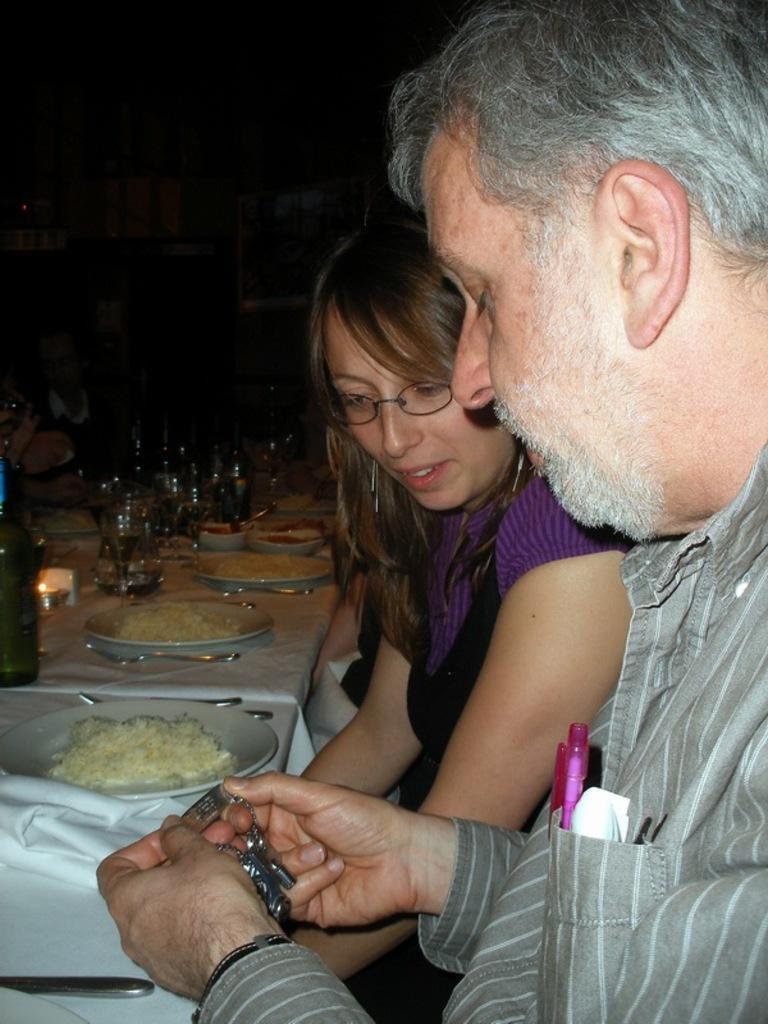Describe this image in one or two sentences. In this image I can see two persons are sitting and in the front I can see one of them is holding a silver colour thing, in his pocket I can see a white colour thing and a pen. On the left side of this image I can see few tables and on it I can see white colour table cloths, number of spoons, plates, glasses and on these plates I can see food. I can also see this image is little bit in dark. 